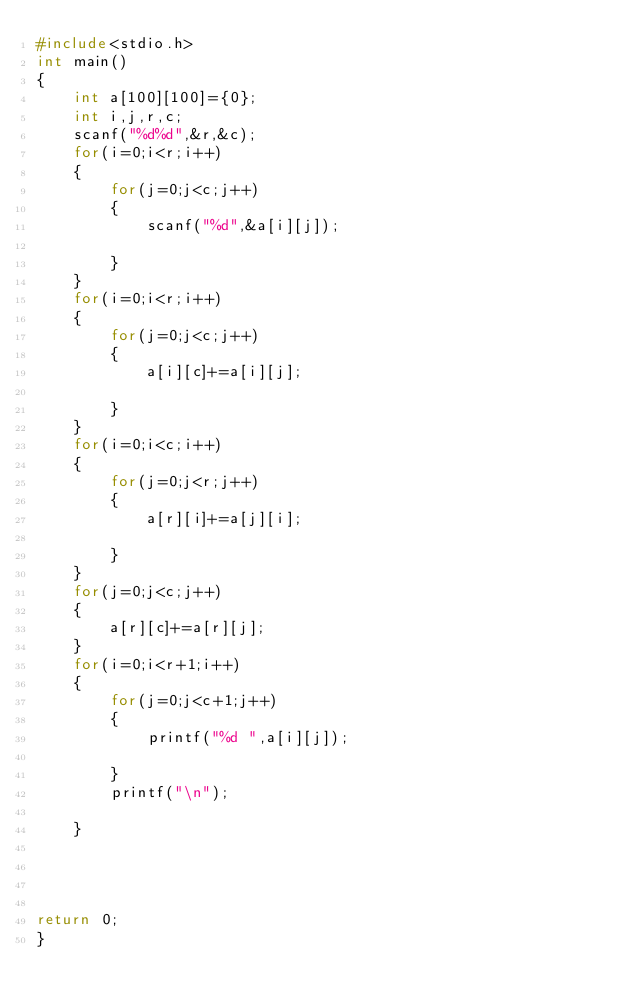Convert code to text. <code><loc_0><loc_0><loc_500><loc_500><_C_>#include<stdio.h>
int main()
{
	int a[100][100]={0};
	int i,j,r,c;
	scanf("%d%d",&r,&c);
	for(i=0;i<r;i++)
	{
		for(j=0;j<c;j++)
		{
			scanf("%d",&a[i][j]);

		}
	}
	for(i=0;i<r;i++)
	{
		for(j=0;j<c;j++)
		{
			a[i][c]+=a[i][j];

		}
	}
	for(i=0;i<c;i++)
	{
		for(j=0;j<r;j++)
		{
			a[r][i]+=a[j][i];
			
		}
	}
	for(j=0;j<c;j++)
	{
		a[r][c]+=a[r][j];
	}
	for(i=0;i<r+1;i++)
	{
		for(j=0;j<c+1;j++)
		{
			printf("%d ",a[i][j]);

		}
		printf("\n");

	}




return 0;
}</code> 